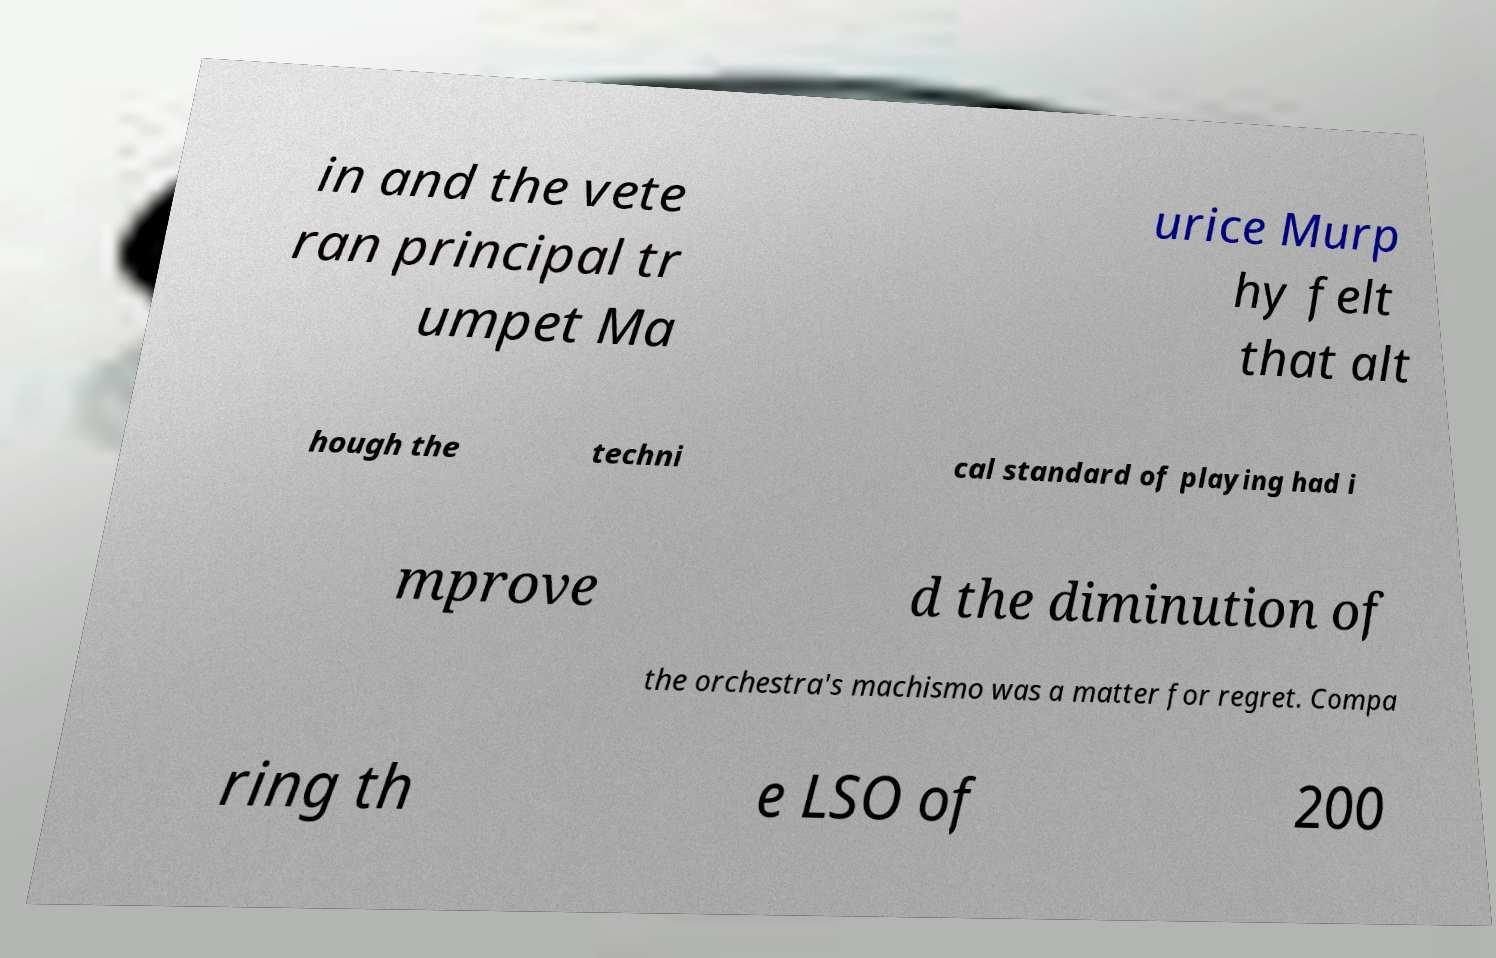Could you assist in decoding the text presented in this image and type it out clearly? in and the vete ran principal tr umpet Ma urice Murp hy felt that alt hough the techni cal standard of playing had i mprove d the diminution of the orchestra's machismo was a matter for regret. Compa ring th e LSO of 200 